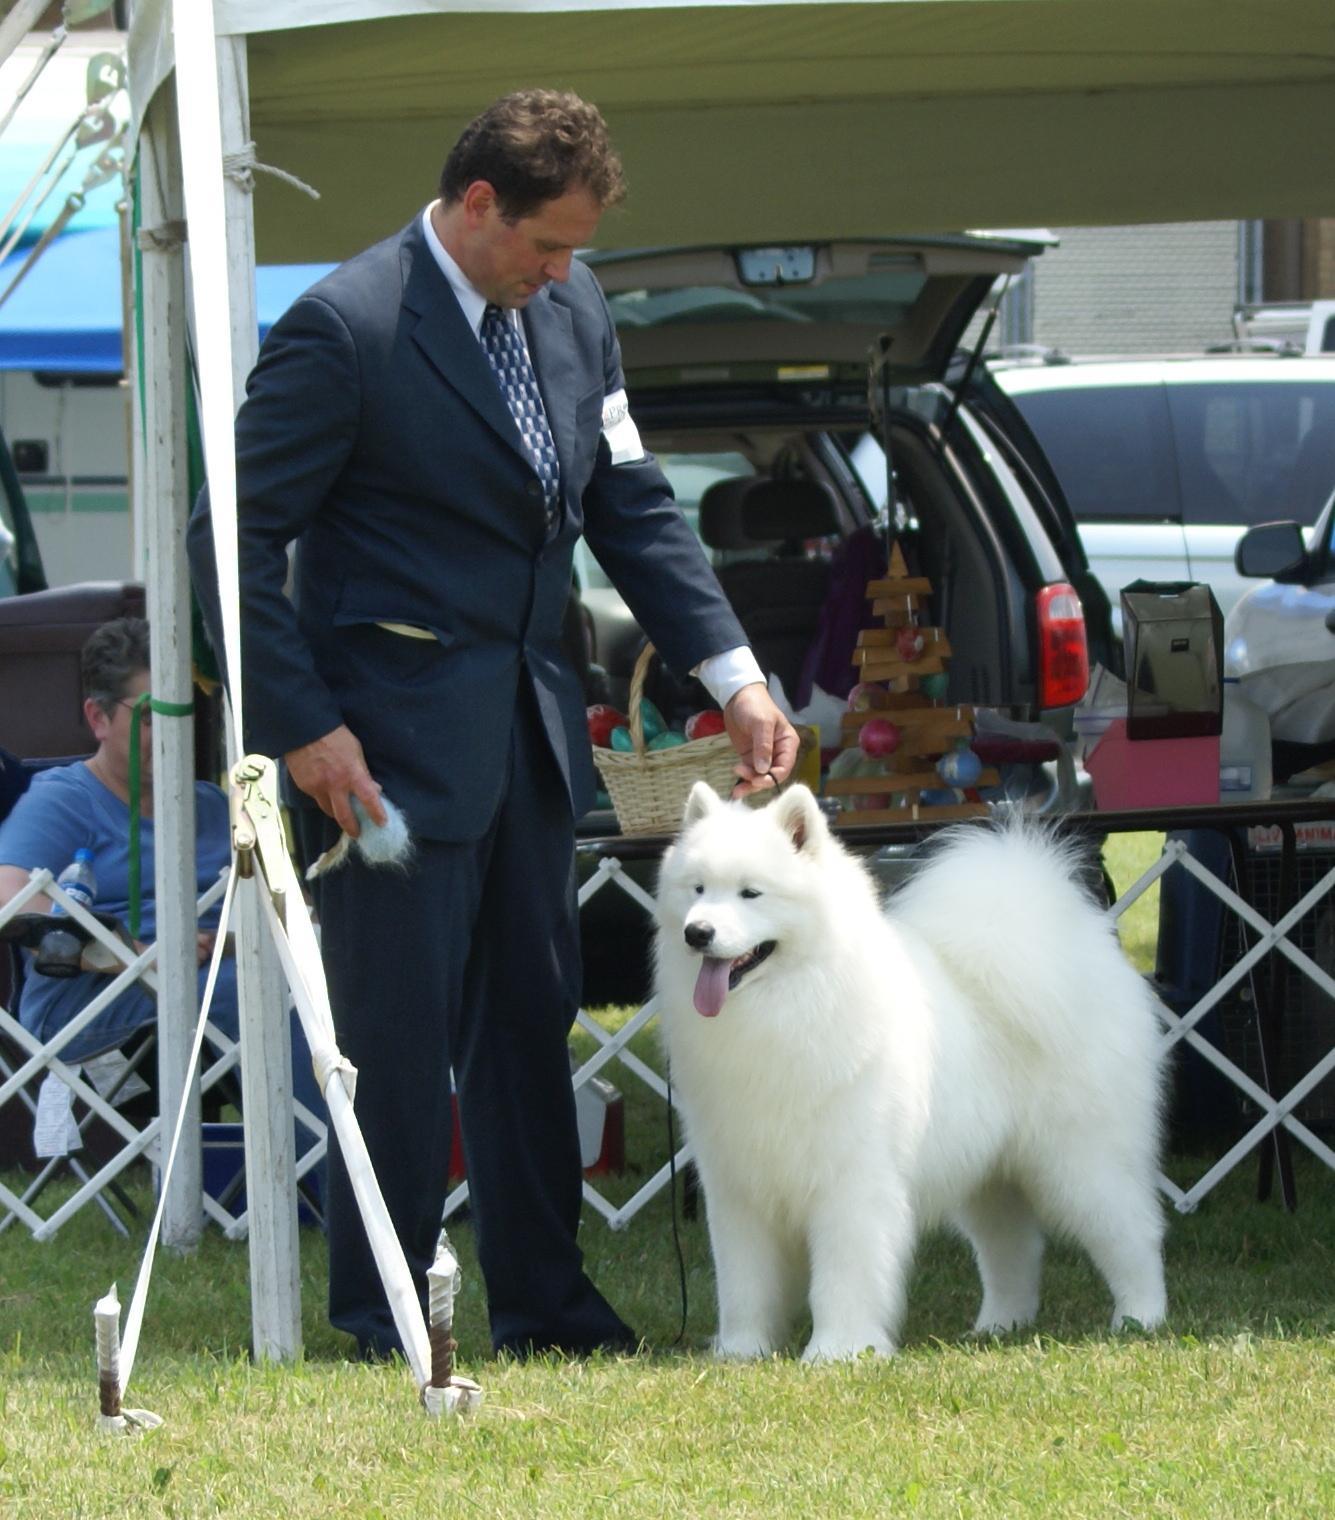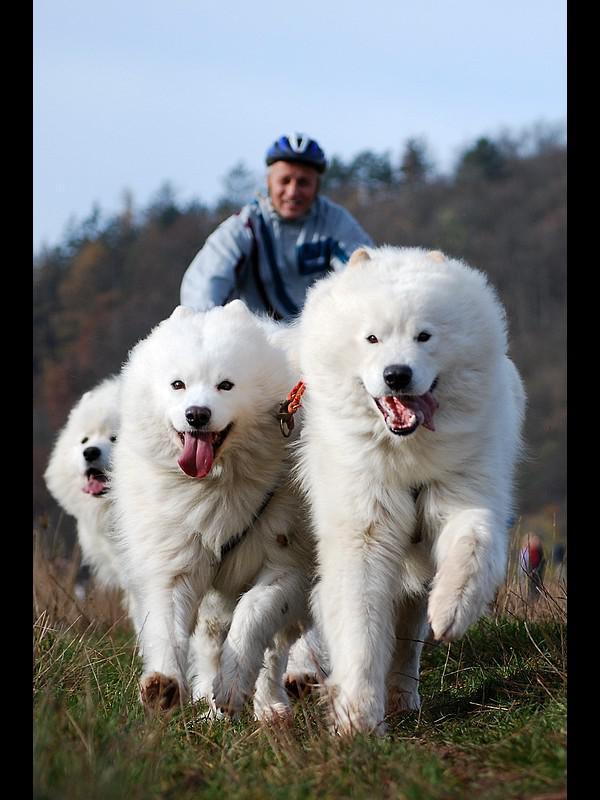The first image is the image on the left, the second image is the image on the right. Examine the images to the left and right. Is the description "Dogs are running together." accurate? Answer yes or no. Yes. The first image is the image on the left, the second image is the image on the right. For the images shown, is this caption "One image features a man in a suit reaching toward a standing white dog in front of white lattice fencing, and the other image features a team of hitched white dogs with a rider behind them." true? Answer yes or no. Yes. 